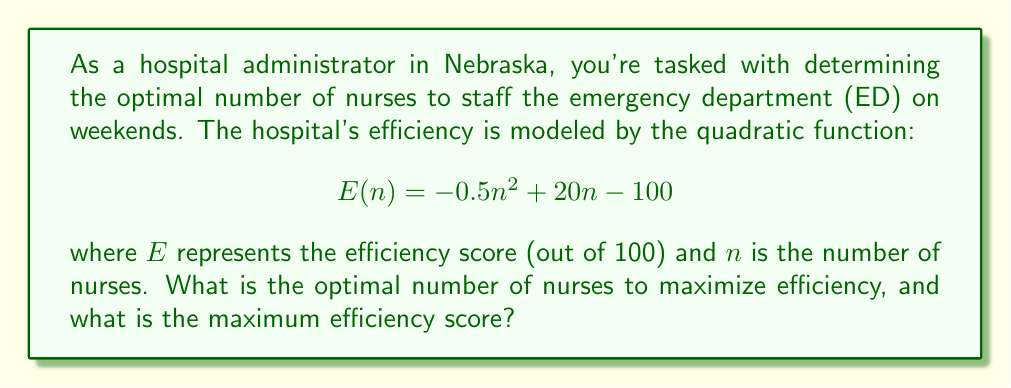Could you help me with this problem? To solve this problem, we need to find the maximum point of the quadratic function. The steps are as follows:

1) The quadratic function is in the form $f(x) = ax^2 + bx + c$, where:
   $a = -0.5$, $b = 20$, and $c = -100$

2) For a quadratic function, the x-coordinate of the vertex (which gives us the optimal number of nurses) is given by the formula:

   $$x = -\frac{b}{2a}$$

3) Substituting our values:

   $$n = -\frac{20}{2(-0.5)} = -\frac{20}{-1} = 20$$

4) To find the maximum efficiency score, we substitute this value of $n$ back into the original function:

   $$E(20) = -0.5(20)^2 + 20(20) - 100$$
   $$= -0.5(400) + 400 - 100$$
   $$= -200 + 400 - 100$$
   $$= 100$$

5) Therefore, the optimal number of nurses is 20, and the maximum efficiency score is 100.
Answer: The optimal number of nurses is 20, and the maximum efficiency score is 100. 